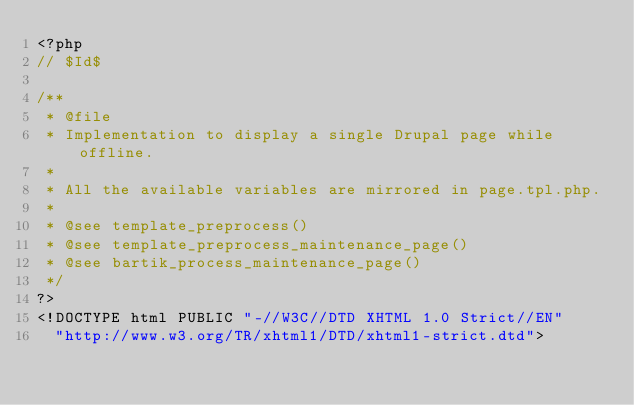<code> <loc_0><loc_0><loc_500><loc_500><_PHP_><?php
// $Id$

/**
 * @file
 * Implementation to display a single Drupal page while offline.
 *
 * All the available variables are mirrored in page.tpl.php.
 *
 * @see template_preprocess()
 * @see template_preprocess_maintenance_page()
 * @see bartik_process_maintenance_page()
 */
?>
<!DOCTYPE html PUBLIC "-//W3C//DTD XHTML 1.0 Strict//EN"
  "http://www.w3.org/TR/xhtml1/DTD/xhtml1-strict.dtd"></code> 